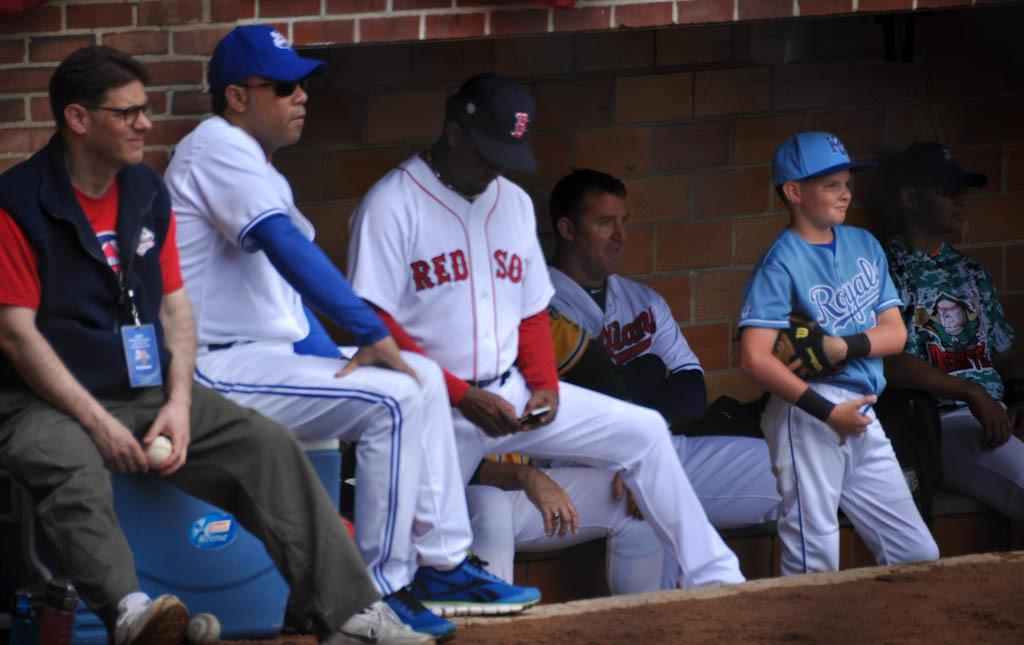<image>
Relay a brief, clear account of the picture shown. a player that is wearing a red sox jersey 